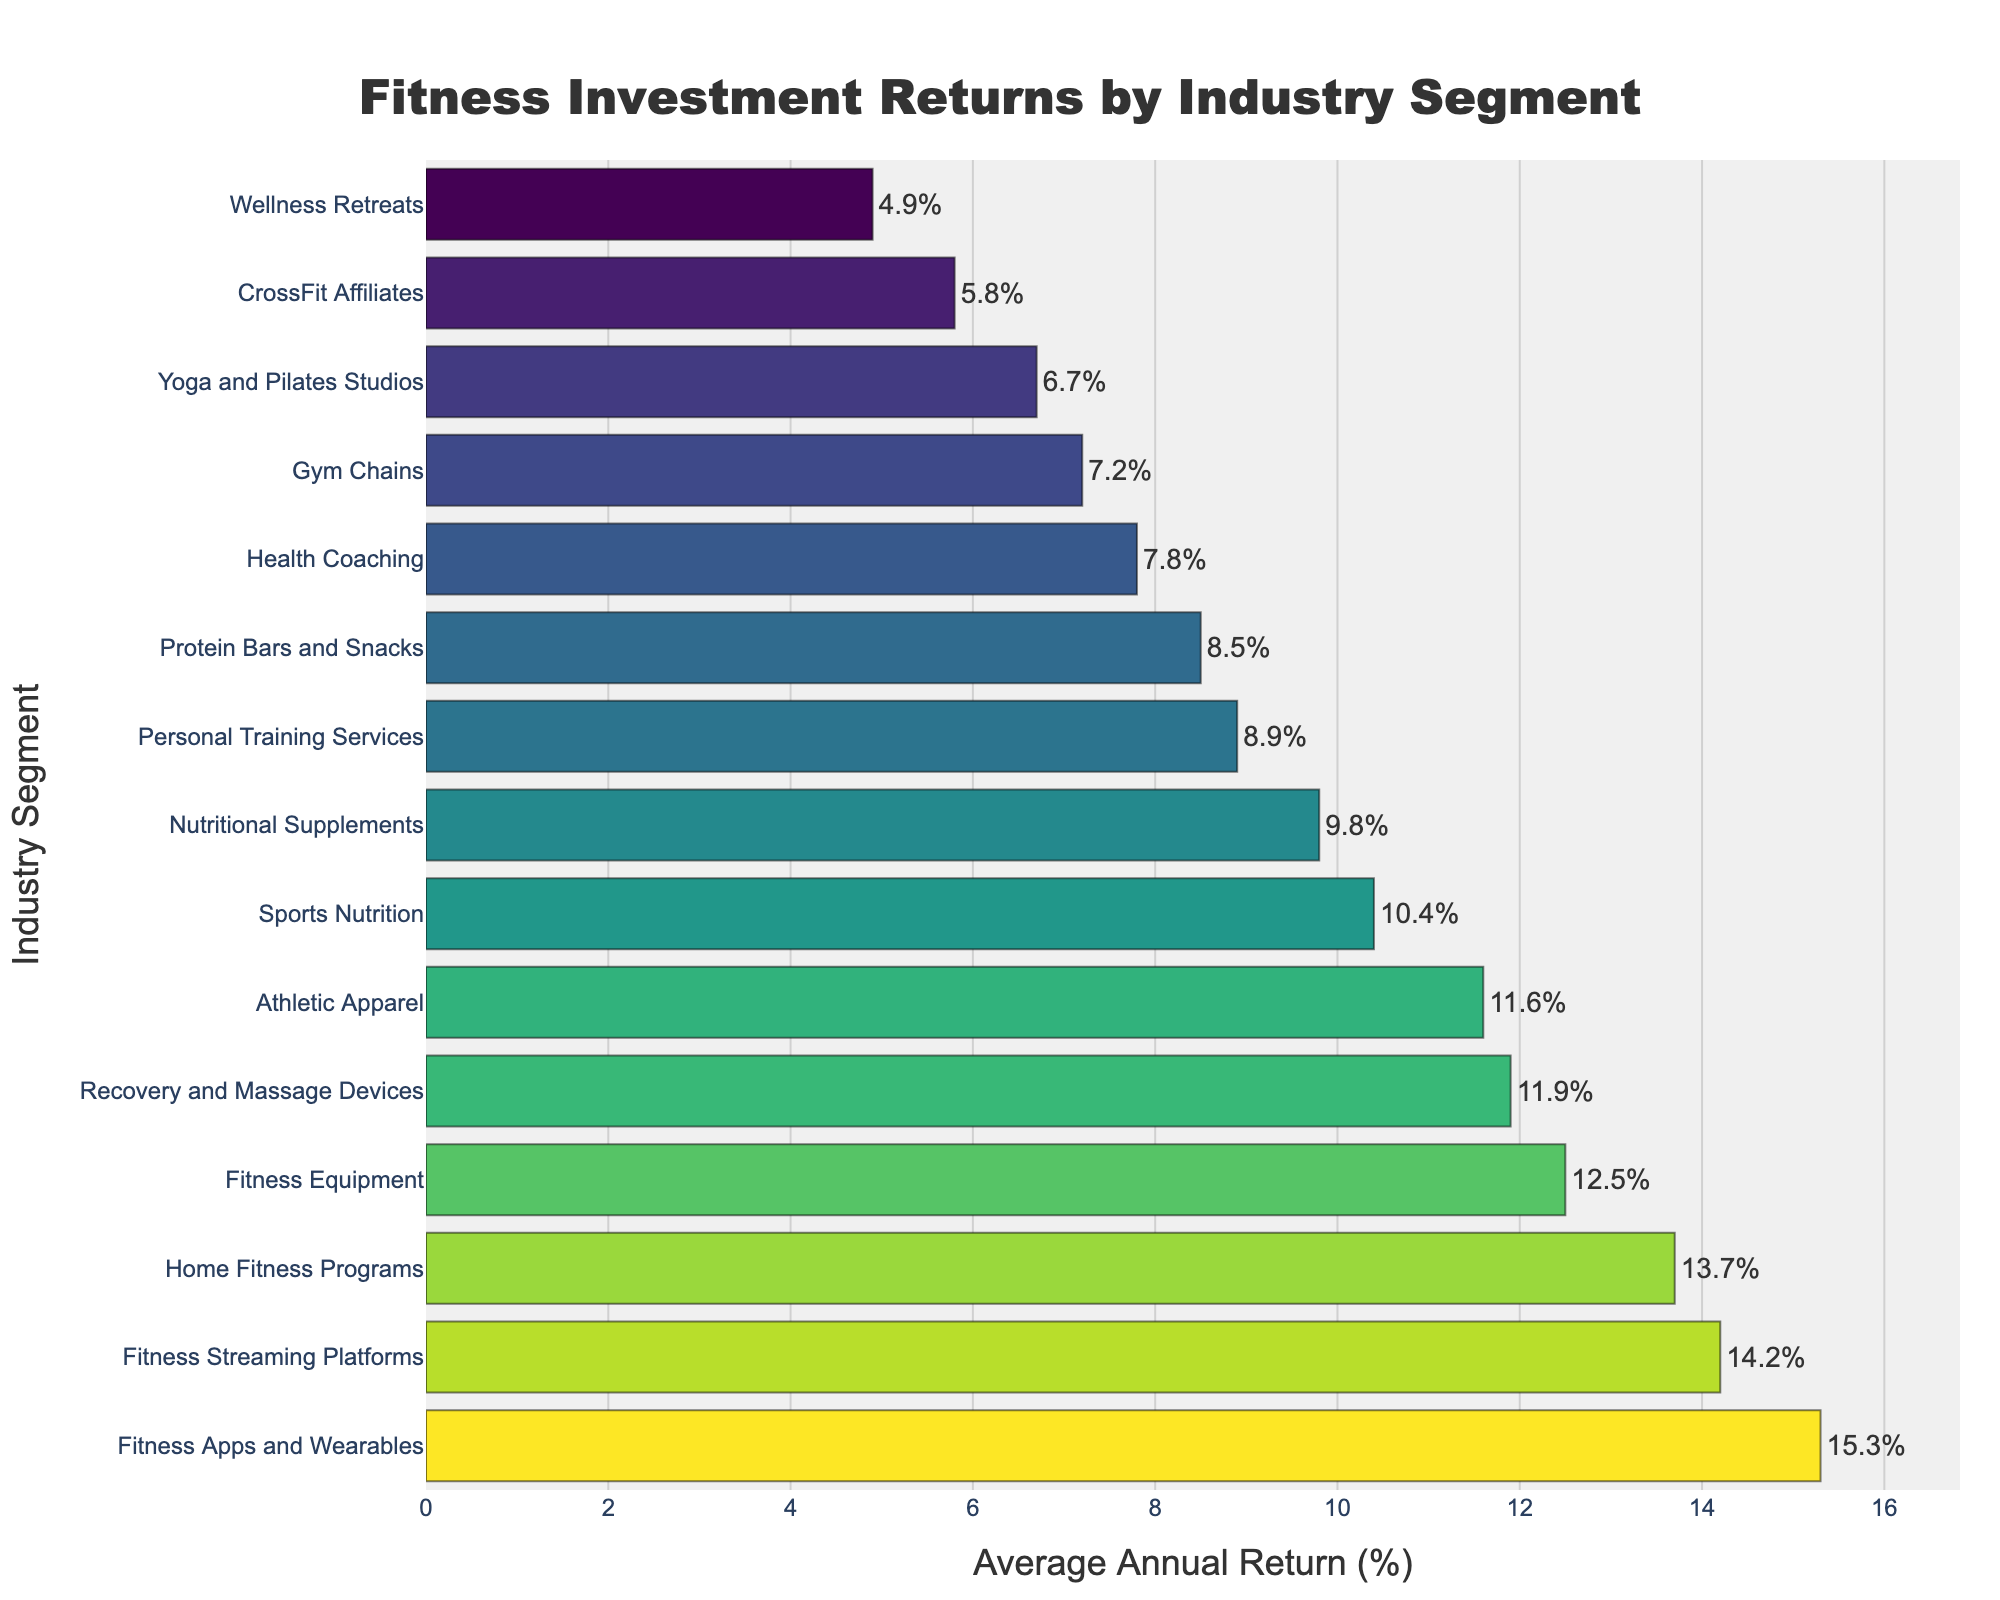Which industry segment has the highest average annual return? The average annual return for each industry segment is given, and from the bar chart, the highest average annual return belongs to the segment at the top of the chart. This segment is "Fitness Apps and Wearables."
Answer: Fitness Apps and Wearables Which industry segment has the lowest average annual return? The average annual return for each industry segment is given, and from the bar chart, the lowest average annual return belongs to the segment at the bottom of the chart. This segment is "Wellness Retreats."
Answer: Wellness Retreats What is the average annual return for Gym Chains? By locating "Gym Chains" in the bar chart, we can see its corresponding bar length, which shows an average annual return of 7.2%.
Answer: 7.2% How many industry segments have an average annual return above 10%? From the bar chart, count the segments with bars extending beyond the 10% mark. There are 8 segments: Fitness Equipment, Fitness Apps and Wearables, Athletic Apparel, Home Fitness Programs, Fitness Streaming Platforms, Sports Nutrition, Nutritional Supplements, and Recovery and Massage Devices.
Answer: 8 What is the difference in average annual return between CrossFit Affiliates and Personal Training Services? The bar for CrossFit Affiliates shows 5.8%, while Personal Training Services shows 8.9%. The difference is 8.9% - 5.8% = 3.1%.
Answer: 3.1% Which has a higher average annual return: Protein Bars and Snacks or Health Coaching? By comparing the bar lengths, "Protein Bars and Snacks" has an average annual return of 8.5%, while "Health Coaching" has 7.8%. Therefore, Protein Bars and Snacks has a higher return.
Answer: Protein Bars and Snacks What is the total average annual return for Fitness Equipment, Gym Chains, and Wellness Retreats? Add the average annual returns for each segment: Fitness Equipment (12.5%), Gym Chains (7.2%), and Wellness Retreats (4.9%). The total is 12.5 + 7.2 + 4.9 = 24.6%.
Answer: 24.6% Which industry segment has an average annual return closest to 10%? "Sports Nutrition" shows an average annual return of 10.4%, which is closest to 10%.
Answer: Sports Nutrition What is the average of the average annual returns for the top three industry segments? The top three segments are Fitness Apps and Wearables (15.3%), Home Fitness Programs (13.7%), and Fitness Streaming Platforms (14.2%). The average is (15.3 + 13.7 + 14.2) / 3 = 14.4%.
Answer: 14.4% Between Yoga and Pilates Studios and Recovery and Massage Devices, which segment shows a greater average annual return and by how much? Compare the average annual returns: Yoga and Pilates Studios (6.7%) and Recovery and Massage Devices (11.9%). The difference is 11.9% - 6.7% = 5.2%. Recovery and Massage Devices has a higher return by 5.2%.
Answer: Recovery and Massage Devices, 5.2% 